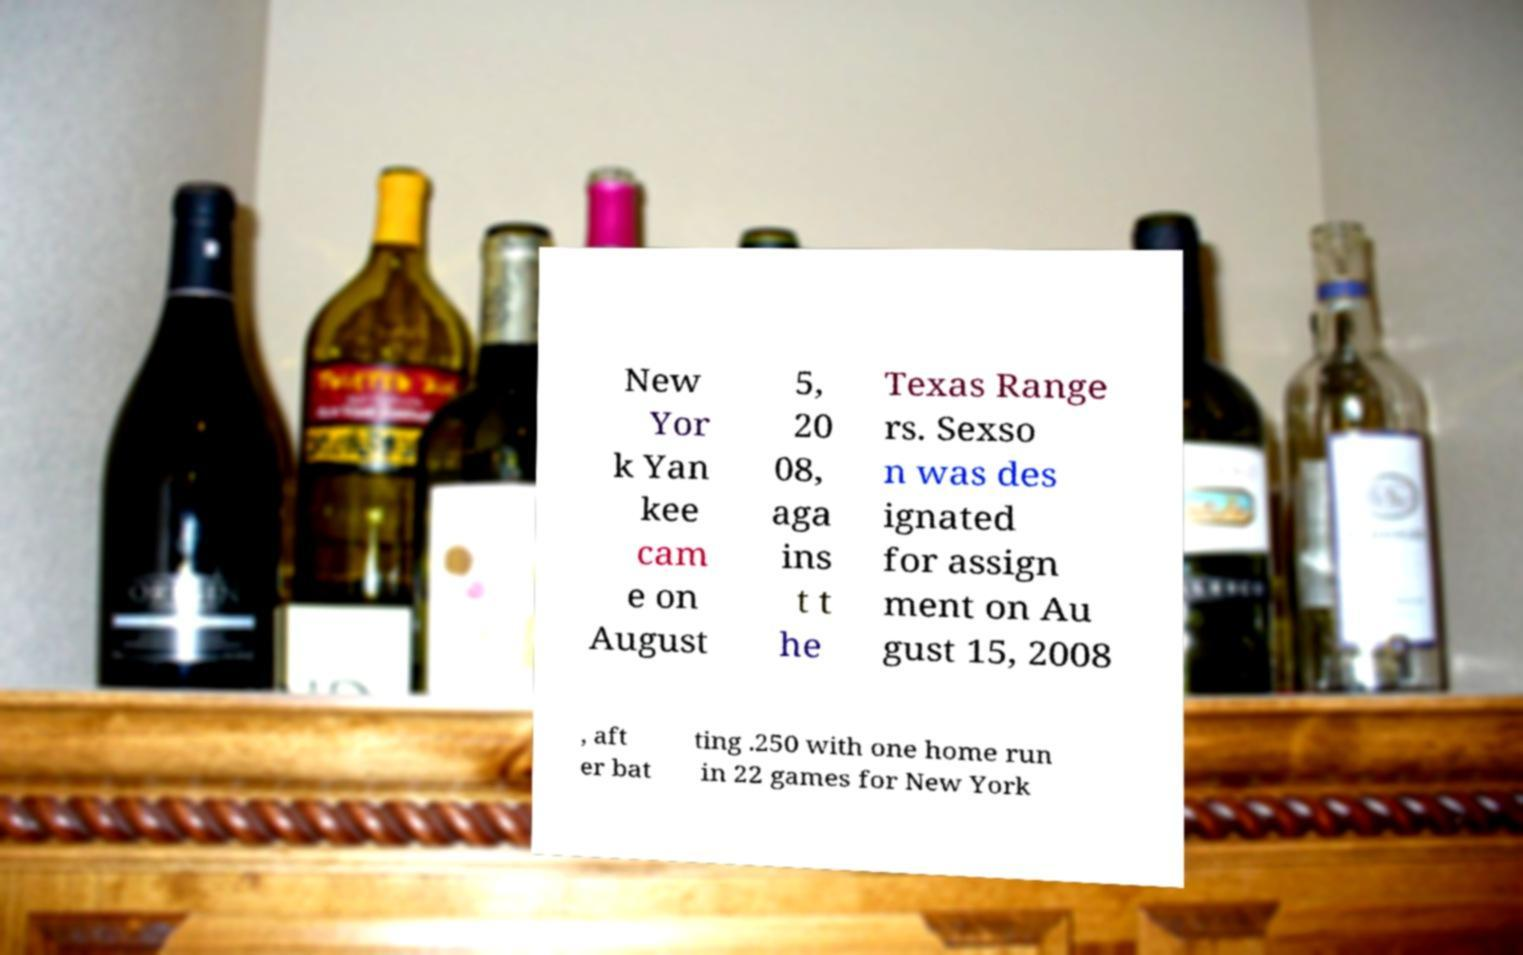I need the written content from this picture converted into text. Can you do that? New Yor k Yan kee cam e on August 5, 20 08, aga ins t t he Texas Range rs. Sexso n was des ignated for assign ment on Au gust 15, 2008 , aft er bat ting .250 with one home run in 22 games for New York 